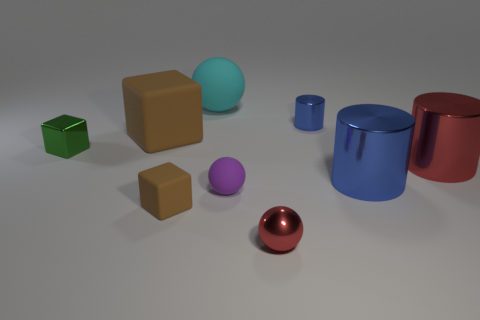Are there any patterns or consistencies in the colors of the objects? The objects in the image display a variety of colors with no discernible pattern. The colors include green, tan, purple, cyan, blue, and red. Each object is uniformly colored and maintains a solid tone, contributing to a colorful but random assortment. 